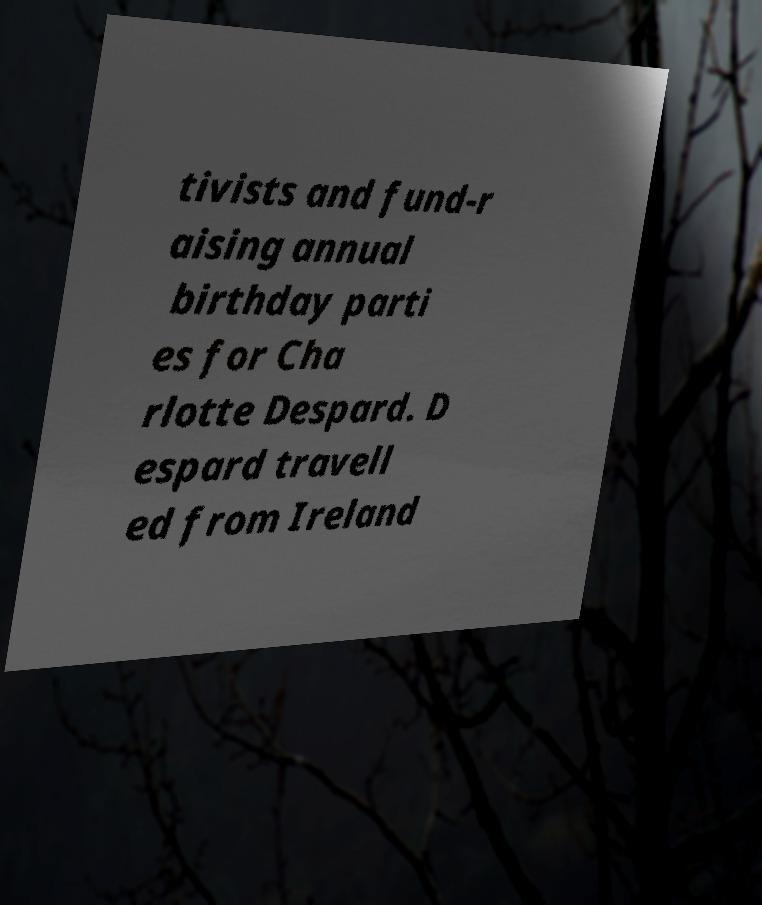Can you accurately transcribe the text from the provided image for me? tivists and fund-r aising annual birthday parti es for Cha rlotte Despard. D espard travell ed from Ireland 